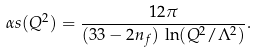<formula> <loc_0><loc_0><loc_500><loc_500>\alpha s ( Q ^ { 2 } ) = \frac { 1 2 \pi } { ( 3 3 - 2 n _ { f } ) \, \ln ( Q ^ { 2 } / \Lambda ^ { 2 } ) } .</formula> 